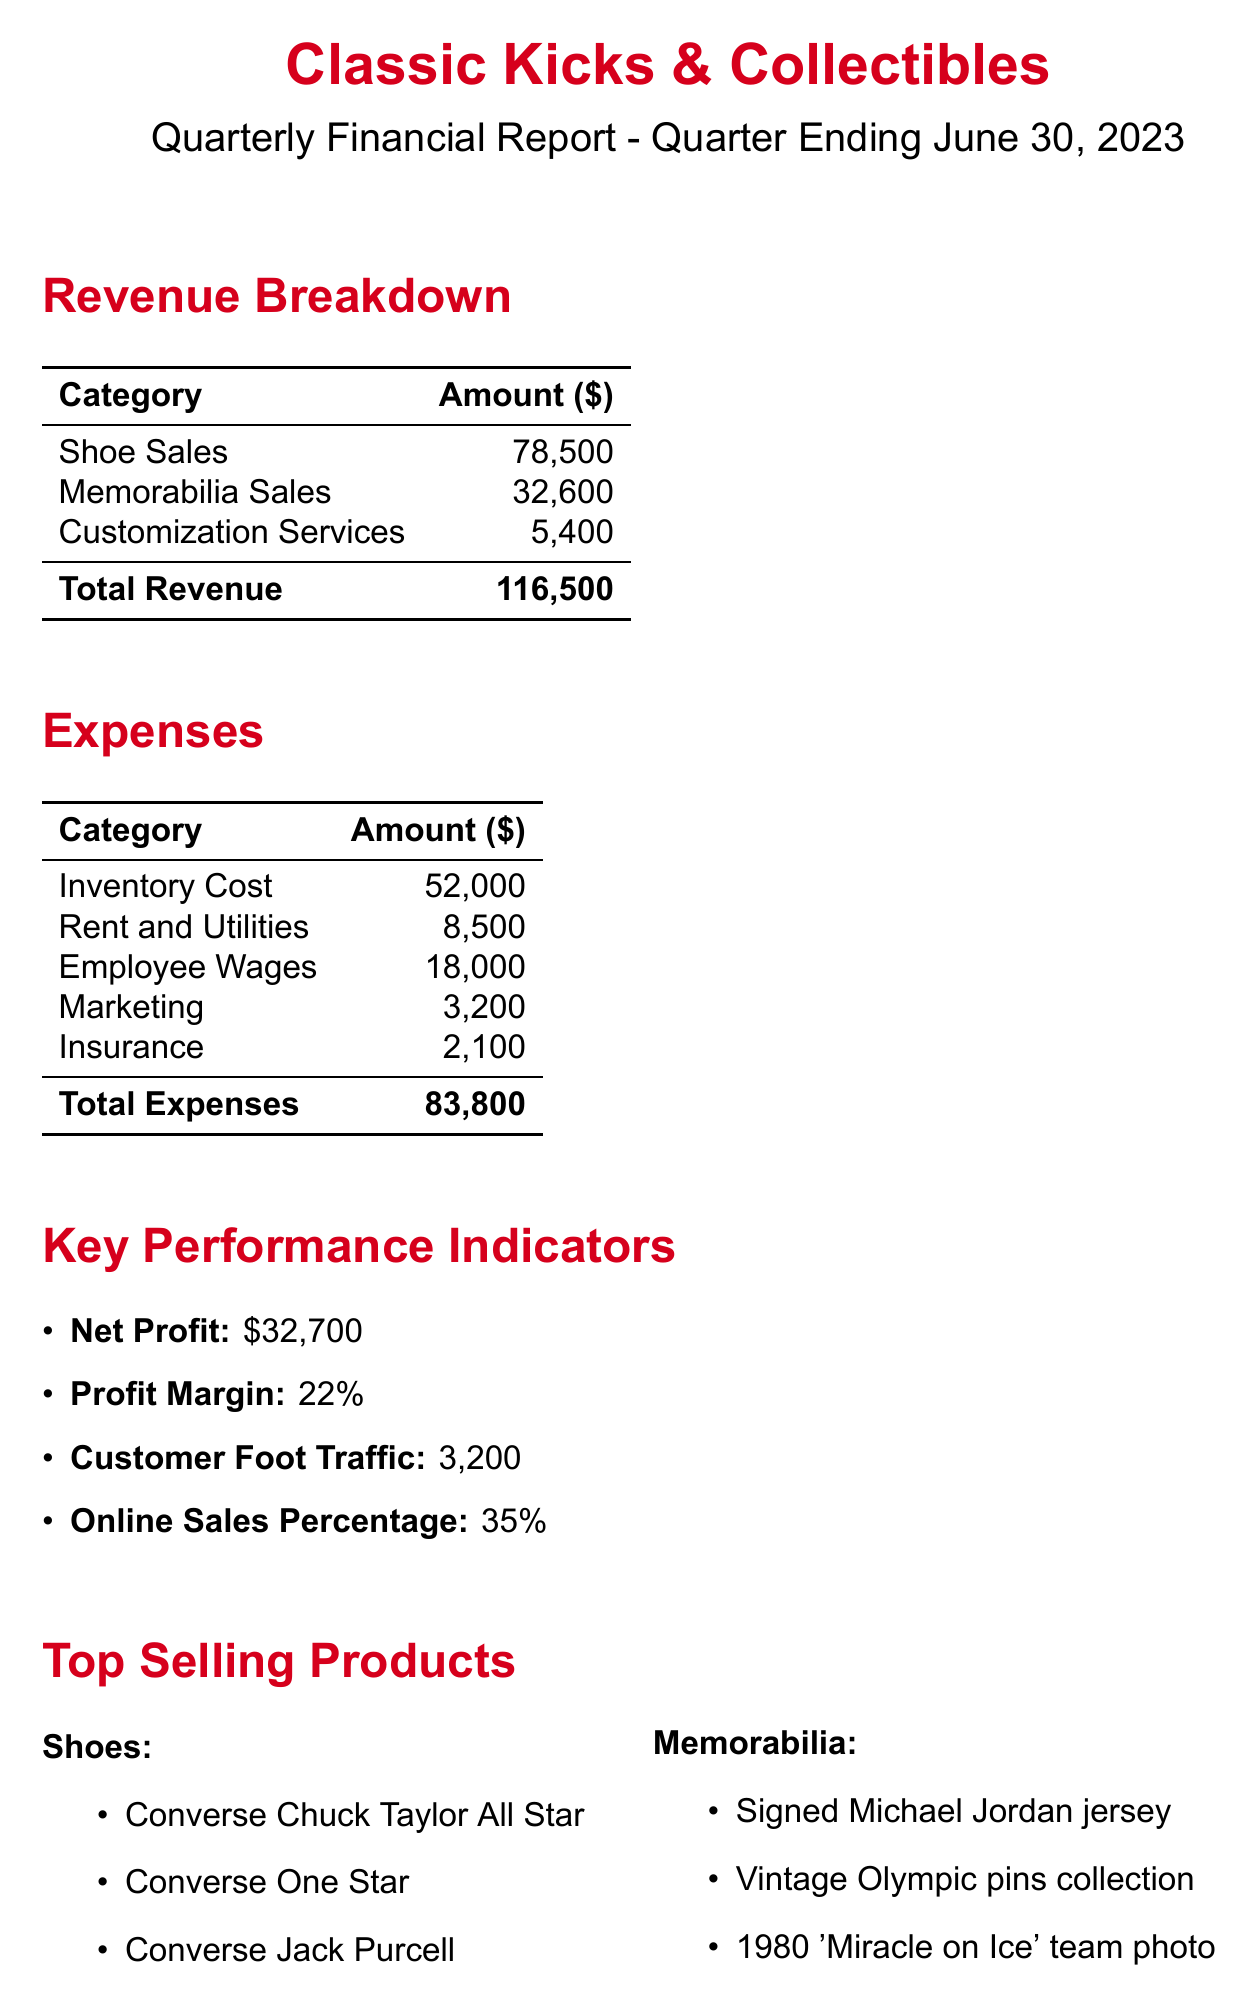What is the shop's name? The name of the shop is provided at the top of the document as "Classic Kicks & Collectibles."
Answer: Classic Kicks & Collectibles What is the total revenue? The total revenue is calculated by summing all revenue categories: shoe sales, memorabilia sales, and customization services, which total to $116,500.
Answer: $116,500 What are the top-selling shoes? The document lists three top-selling shoes, which are mentioned in a specific section.
Answer: Converse Chuck Taylor All Star, Converse One Star, Converse Jack Purcell What is the profit margin? The profit margin is given in the Key Performance Indicators section and it quantifies the profitability of the shop.
Answer: 22% What were the total expenses? Total expenses are listed in a table that summarizes all costs incurred by the shop for the quarter.
Answer: $83,800 Which product line is a collaboration with the NBA? The new product lines section identifies a specific collaboration with the NBA as one of the limited editions.
Answer: Limited edition Converse x NBA collaboration How many customers visited the shop? The Key Performance Indicators section states the number of customer foot traffic for the quarter.
Answer: 3,200 What is the percentage of online sales? The document includes a specific statistic regarding online sales in the Key Performance Indicators section.
Answer: 35% What is the cost of employee wages? The expenses table includes a specific line item that states the amount spent on employee wages.
Answer: $18,000 